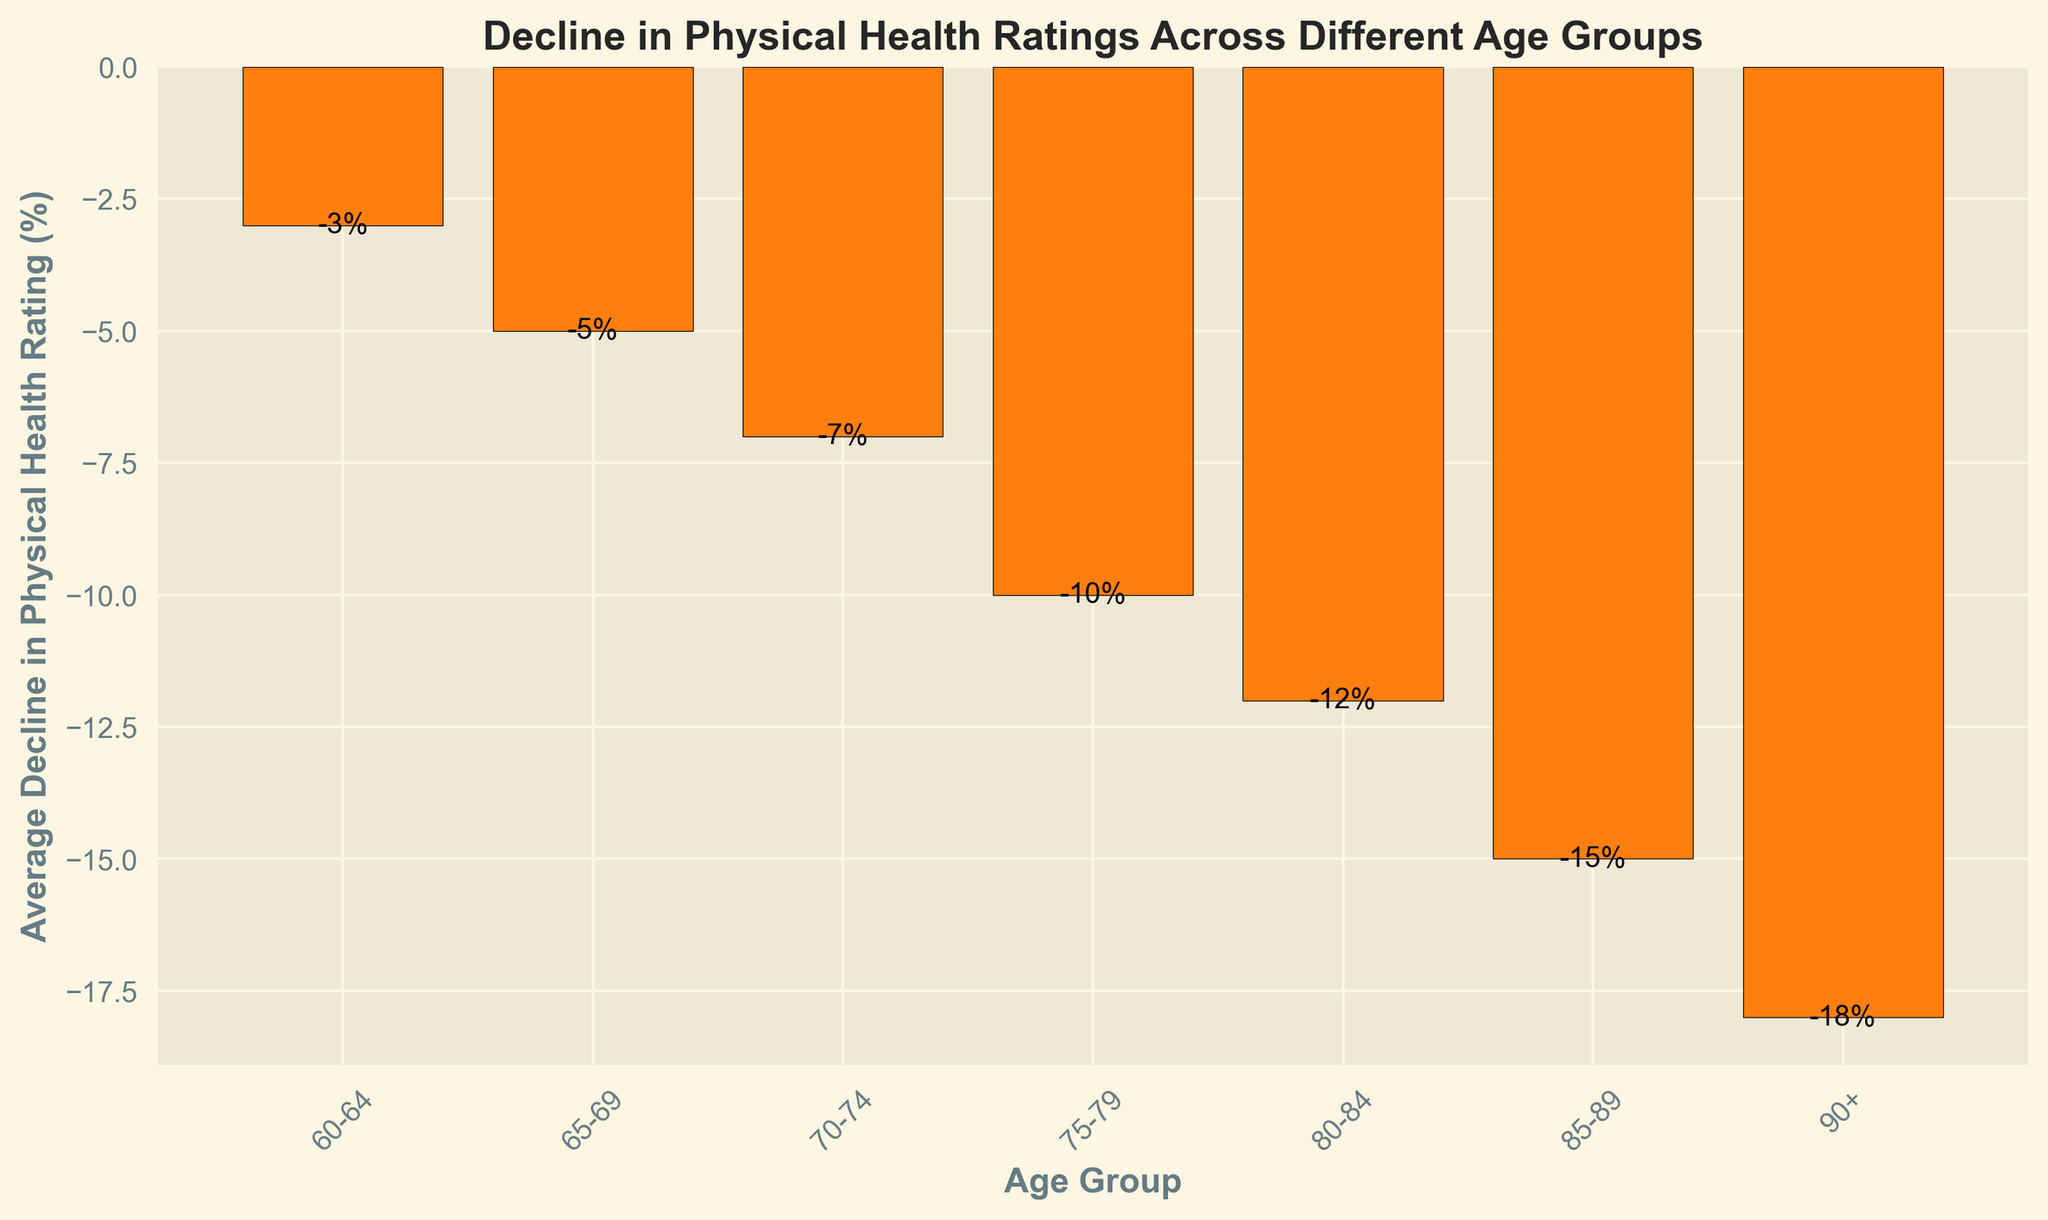What age group has the highest average decline in physical health rating? The group with the most negative value on the y-axis represents the highest decline. The 90+ age group has the most negative value at -18%.
Answer: 90+ Which age group has a decline of -10% in physical health rating? By examining the y-axis values, the age group 75-79 is associated with a decline of -10%.
Answer: 75-79 How much larger is the decline in physical health rating for the 90+ age group compared to the 60-64 age group? Subtract the value of the 60-64 age group’s decline from the 90+ age group’s decline: -18% - (-3%) = -15%. The decline is 15 percentage points larger.
Answer: 15% Which age group shows a decline in physical health rating of -12%? By looking at the y-axis values, the age group 80-84 shows a decline of -12%.
Answer: 80-84 What's the difference in physical health rating decline between the age groups 70-74 and 85-89? Subtract the decline percentage of 70-74 from 85-89: -15% - (-7%) = -8%. The difference is 8 percentage points.
Answer: 8% What is the average decline in physical health rating for age groups 65-69 and 80-84 combined? Add the two percentages: -5% + (-12%) = -17%, then divide by 2: -17% / 2 = -8.5%.
Answer: -8.5% Identify the trend based on the decline percentages across the age groups. The trend shows progressively greater negative values as the age groups increase, indicating that the decline in physical health ratings worsens with age.
Answer: Decline worsens with age How much larger is the decline for the 85-89 age group compared to the 75-79 age group? Subtract the decline percentage of 75-79 from 85-89: -15% - (-10%) = -5%. The decline is 5 percentage points larger.
Answer: 5% What can be inferred visually about the overall pattern of physical health decline based on the height of the bars? Taller bars represent more negative values, which indicate greater declines in physical health. The bars become progressively taller as the age groups increase, showing the pattern of increasing health decline with age.
Answer: Increases with age 